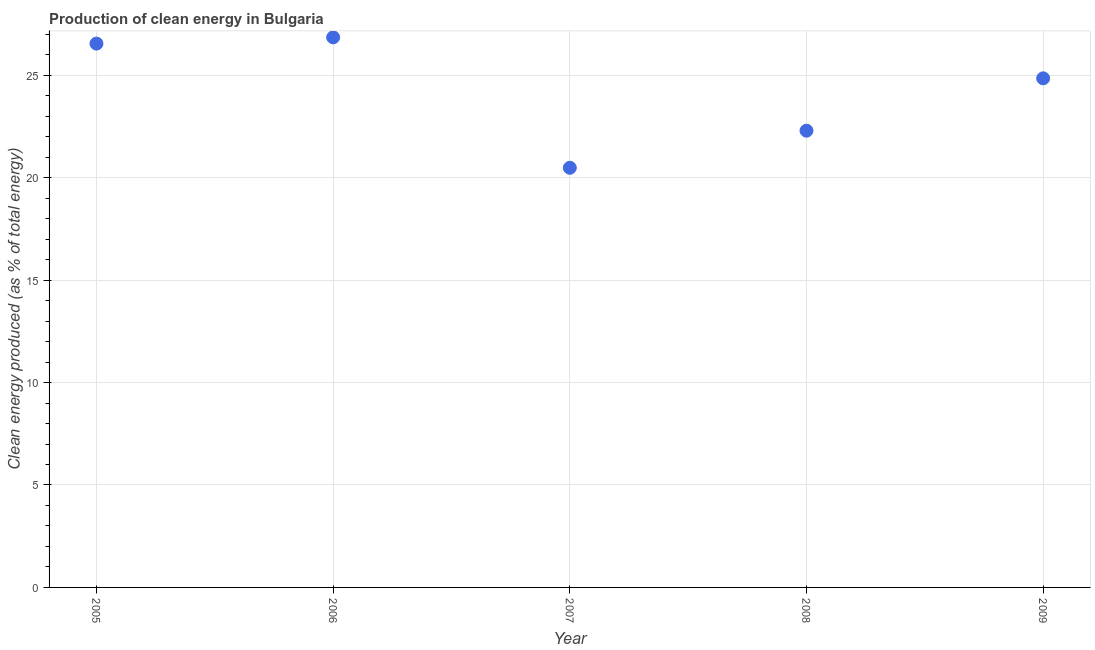What is the production of clean energy in 2007?
Make the answer very short. 20.48. Across all years, what is the maximum production of clean energy?
Offer a very short reply. 26.85. Across all years, what is the minimum production of clean energy?
Offer a terse response. 20.48. In which year was the production of clean energy minimum?
Keep it short and to the point. 2007. What is the sum of the production of clean energy?
Give a very brief answer. 121.01. What is the difference between the production of clean energy in 2006 and 2008?
Give a very brief answer. 4.56. What is the average production of clean energy per year?
Provide a short and direct response. 24.2. What is the median production of clean energy?
Your response must be concise. 24.85. In how many years, is the production of clean energy greater than 14 %?
Ensure brevity in your answer.  5. Do a majority of the years between 2007 and 2008 (inclusive) have production of clean energy greater than 6 %?
Keep it short and to the point. Yes. What is the ratio of the production of clean energy in 2005 to that in 2007?
Your response must be concise. 1.3. Is the production of clean energy in 2006 less than that in 2008?
Your response must be concise. No. Is the difference between the production of clean energy in 2005 and 2008 greater than the difference between any two years?
Offer a terse response. No. What is the difference between the highest and the second highest production of clean energy?
Your response must be concise. 0.31. Is the sum of the production of clean energy in 2005 and 2008 greater than the maximum production of clean energy across all years?
Make the answer very short. Yes. What is the difference between the highest and the lowest production of clean energy?
Offer a terse response. 6.37. In how many years, is the production of clean energy greater than the average production of clean energy taken over all years?
Your answer should be compact. 3. Does the production of clean energy monotonically increase over the years?
Your answer should be very brief. No. How many dotlines are there?
Make the answer very short. 1. How many years are there in the graph?
Make the answer very short. 5. Are the values on the major ticks of Y-axis written in scientific E-notation?
Offer a terse response. No. What is the title of the graph?
Give a very brief answer. Production of clean energy in Bulgaria. What is the label or title of the X-axis?
Offer a very short reply. Year. What is the label or title of the Y-axis?
Make the answer very short. Clean energy produced (as % of total energy). What is the Clean energy produced (as % of total energy) in 2005?
Offer a very short reply. 26.54. What is the Clean energy produced (as % of total energy) in 2006?
Keep it short and to the point. 26.85. What is the Clean energy produced (as % of total energy) in 2007?
Give a very brief answer. 20.48. What is the Clean energy produced (as % of total energy) in 2008?
Give a very brief answer. 22.29. What is the Clean energy produced (as % of total energy) in 2009?
Your answer should be compact. 24.85. What is the difference between the Clean energy produced (as % of total energy) in 2005 and 2006?
Your response must be concise. -0.31. What is the difference between the Clean energy produced (as % of total energy) in 2005 and 2007?
Your response must be concise. 6.06. What is the difference between the Clean energy produced (as % of total energy) in 2005 and 2008?
Your response must be concise. 4.25. What is the difference between the Clean energy produced (as % of total energy) in 2005 and 2009?
Provide a short and direct response. 1.69. What is the difference between the Clean energy produced (as % of total energy) in 2006 and 2007?
Give a very brief answer. 6.37. What is the difference between the Clean energy produced (as % of total energy) in 2006 and 2008?
Your answer should be compact. 4.56. What is the difference between the Clean energy produced (as % of total energy) in 2006 and 2009?
Ensure brevity in your answer.  2. What is the difference between the Clean energy produced (as % of total energy) in 2007 and 2008?
Offer a very short reply. -1.81. What is the difference between the Clean energy produced (as % of total energy) in 2007 and 2009?
Make the answer very short. -4.37. What is the difference between the Clean energy produced (as % of total energy) in 2008 and 2009?
Give a very brief answer. -2.56. What is the ratio of the Clean energy produced (as % of total energy) in 2005 to that in 2007?
Provide a succinct answer. 1.3. What is the ratio of the Clean energy produced (as % of total energy) in 2005 to that in 2008?
Offer a terse response. 1.19. What is the ratio of the Clean energy produced (as % of total energy) in 2005 to that in 2009?
Keep it short and to the point. 1.07. What is the ratio of the Clean energy produced (as % of total energy) in 2006 to that in 2007?
Your answer should be very brief. 1.31. What is the ratio of the Clean energy produced (as % of total energy) in 2006 to that in 2008?
Make the answer very short. 1.2. What is the ratio of the Clean energy produced (as % of total energy) in 2006 to that in 2009?
Offer a terse response. 1.08. What is the ratio of the Clean energy produced (as % of total energy) in 2007 to that in 2008?
Make the answer very short. 0.92. What is the ratio of the Clean energy produced (as % of total energy) in 2007 to that in 2009?
Your answer should be compact. 0.82. What is the ratio of the Clean energy produced (as % of total energy) in 2008 to that in 2009?
Make the answer very short. 0.9. 